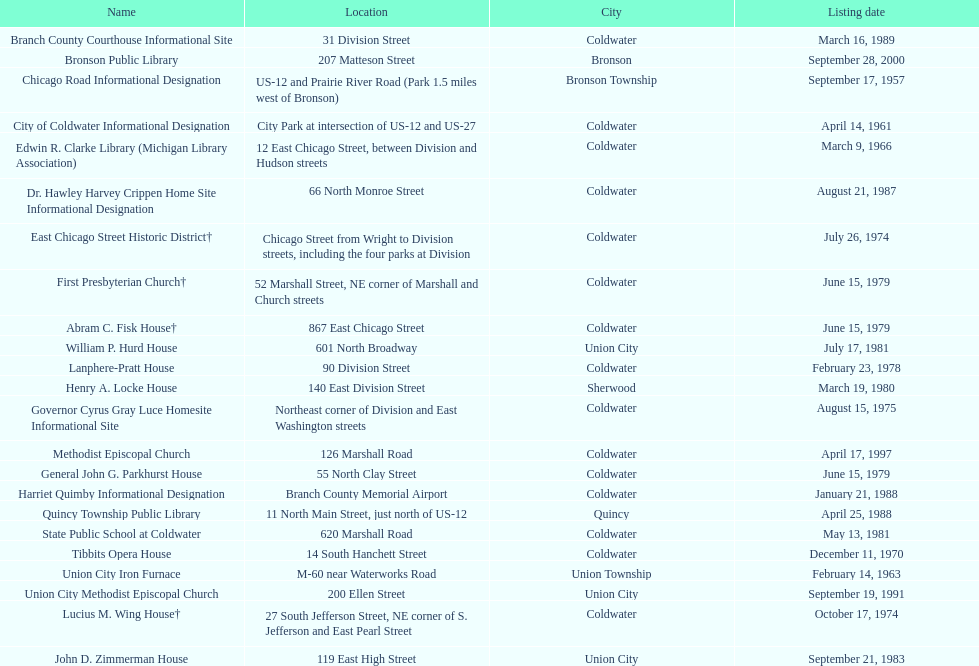Name a site that was listed no later than 1960. Chicago Road Informational Designation. 